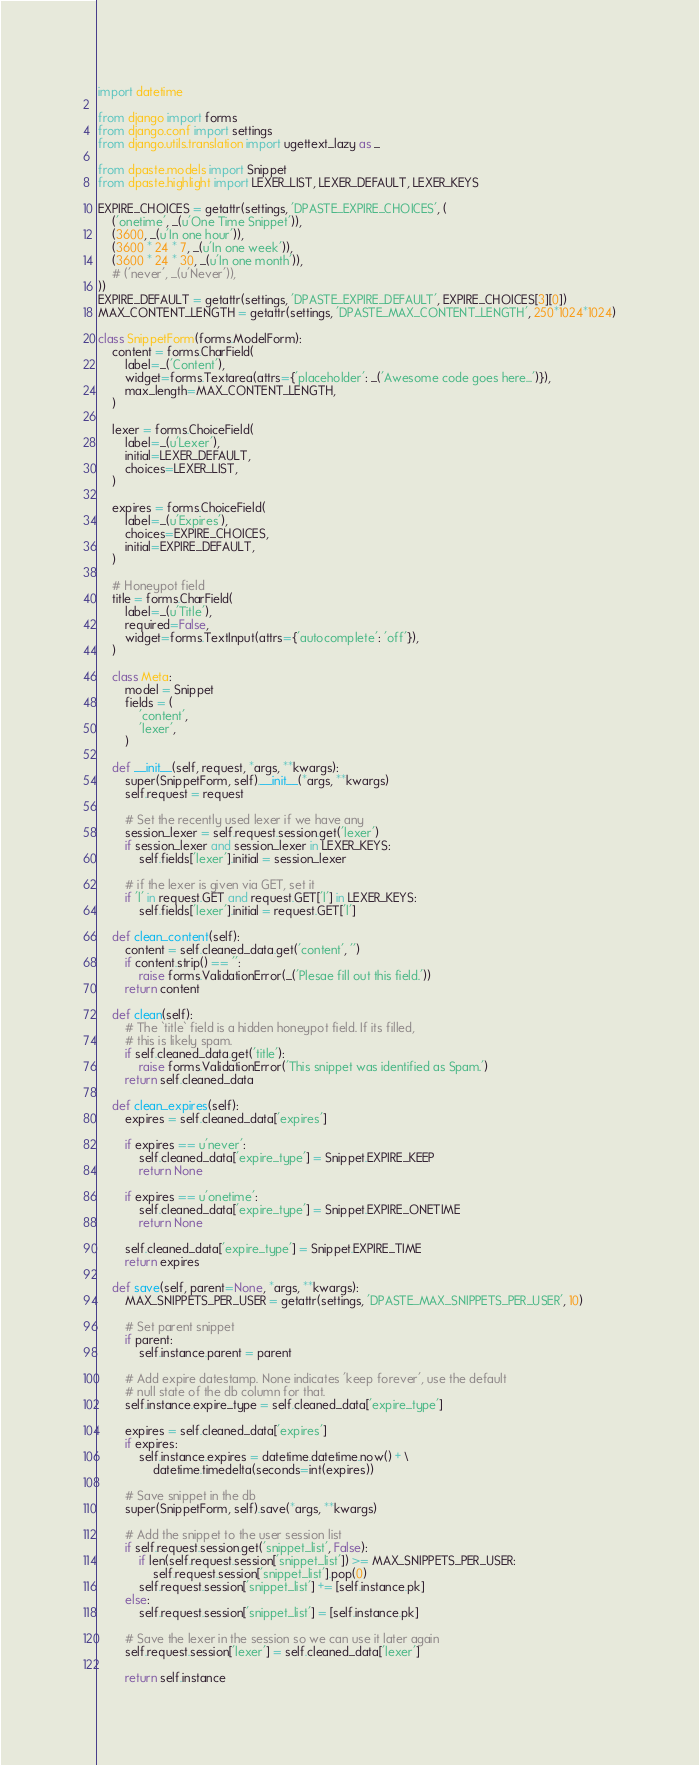Convert code to text. <code><loc_0><loc_0><loc_500><loc_500><_Python_>import datetime

from django import forms
from django.conf import settings
from django.utils.translation import ugettext_lazy as _

from dpaste.models import Snippet
from dpaste.highlight import LEXER_LIST, LEXER_DEFAULT, LEXER_KEYS

EXPIRE_CHOICES = getattr(settings, 'DPASTE_EXPIRE_CHOICES', (
    ('onetime', _(u'One Time Snippet')),
    (3600, _(u'In one hour')),
    (3600 * 24 * 7, _(u'In one week')),
    (3600 * 24 * 30, _(u'In one month')),
    # ('never', _(u'Never')),
))
EXPIRE_DEFAULT = getattr(settings, 'DPASTE_EXPIRE_DEFAULT', EXPIRE_CHOICES[3][0])
MAX_CONTENT_LENGTH = getattr(settings, 'DPASTE_MAX_CONTENT_LENGTH', 250*1024*1024)

class SnippetForm(forms.ModelForm):
    content = forms.CharField(
        label=_('Content'),
        widget=forms.Textarea(attrs={'placeholder': _('Awesome code goes here...')}),
        max_length=MAX_CONTENT_LENGTH,
    )

    lexer = forms.ChoiceField(
        label=_(u'Lexer'),
        initial=LEXER_DEFAULT,
        choices=LEXER_LIST,
    )

    expires = forms.ChoiceField(
        label=_(u'Expires'),
        choices=EXPIRE_CHOICES,
        initial=EXPIRE_DEFAULT,
    )

    # Honeypot field
    title = forms.CharField(
        label=_(u'Title'),
        required=False,
        widget=forms.TextInput(attrs={'autocomplete': 'off'}),
    )

    class Meta:
        model = Snippet
        fields = (
            'content',
            'lexer',
        )

    def __init__(self, request, *args, **kwargs):
        super(SnippetForm, self).__init__(*args, **kwargs)
        self.request = request

        # Set the recently used lexer if we have any
        session_lexer = self.request.session.get('lexer')
        if session_lexer and session_lexer in LEXER_KEYS:
            self.fields['lexer'].initial = session_lexer

        # if the lexer is given via GET, set it
        if 'l' in request.GET and request.GET['l'] in LEXER_KEYS:
            self.fields['lexer'].initial = request.GET['l']

    def clean_content(self):
        content = self.cleaned_data.get('content', '')
        if content.strip() == '':
            raise forms.ValidationError(_('Plesae fill out this field.'))
        return content

    def clean(self):
        # The `title` field is a hidden honeypot field. If its filled,
        # this is likely spam.
        if self.cleaned_data.get('title'):
            raise forms.ValidationError('This snippet was identified as Spam.')
        return self.cleaned_data

    def clean_expires(self):
        expires = self.cleaned_data['expires']

        if expires == u'never':
            self.cleaned_data['expire_type'] = Snippet.EXPIRE_KEEP
            return None

        if expires == u'onetime':
            self.cleaned_data['expire_type'] = Snippet.EXPIRE_ONETIME
            return None

        self.cleaned_data['expire_type'] = Snippet.EXPIRE_TIME
        return expires

    def save(self, parent=None, *args, **kwargs):
        MAX_SNIPPETS_PER_USER = getattr(settings, 'DPASTE_MAX_SNIPPETS_PER_USER', 10)

        # Set parent snippet
        if parent:
            self.instance.parent = parent

        # Add expire datestamp. None indicates 'keep forever', use the default
        # null state of the db column for that.
        self.instance.expire_type = self.cleaned_data['expire_type']

        expires = self.cleaned_data['expires']
        if expires:
            self.instance.expires = datetime.datetime.now() + \
                datetime.timedelta(seconds=int(expires))

        # Save snippet in the db
        super(SnippetForm, self).save(*args, **kwargs)

        # Add the snippet to the user session list
        if self.request.session.get('snippet_list', False):
            if len(self.request.session['snippet_list']) >= MAX_SNIPPETS_PER_USER:
                self.request.session['snippet_list'].pop(0)
            self.request.session['snippet_list'] += [self.instance.pk]
        else:
            self.request.session['snippet_list'] = [self.instance.pk]

        # Save the lexer in the session so we can use it later again
        self.request.session['lexer'] = self.cleaned_data['lexer']

        return self.instance
</code> 